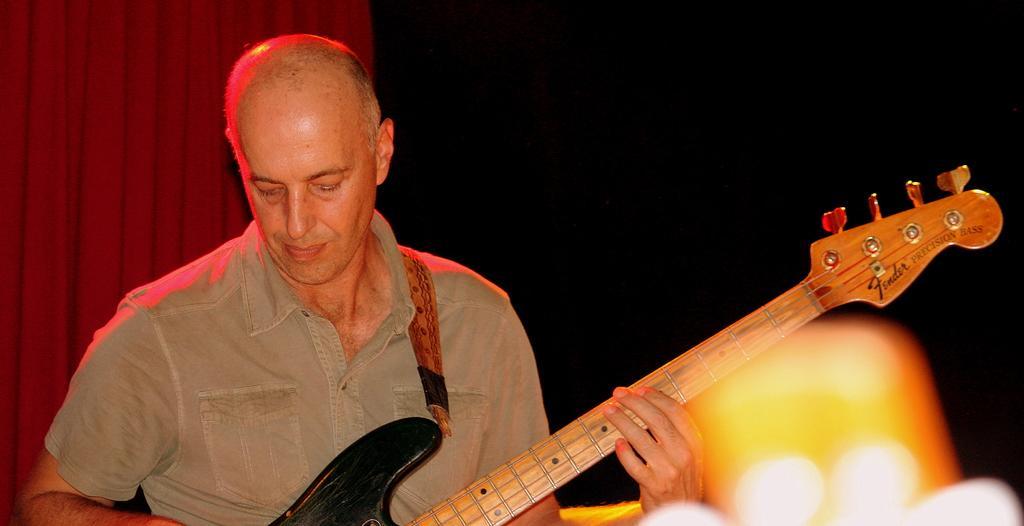How would you summarize this image in a sentence or two? This picture shows a man holding a guitar in his hands and playing it. In the background there is a red color curtain. 